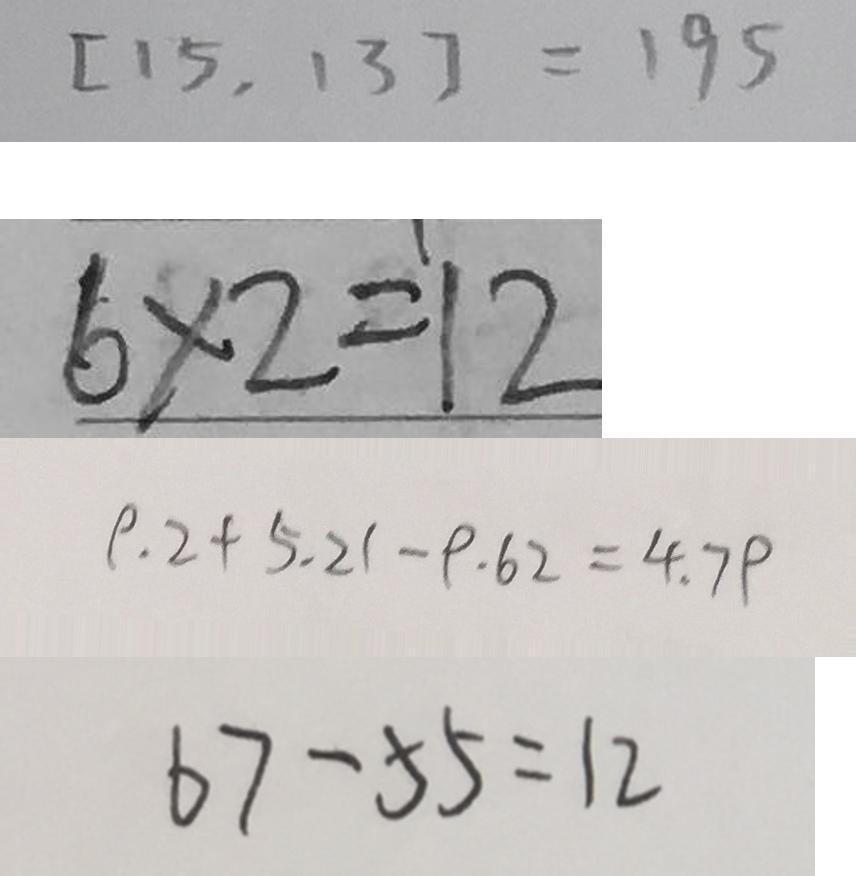<formula> <loc_0><loc_0><loc_500><loc_500>[ 1 5 , 1 3 ] = 1 9 5 
 6 \times 2 = 1 2 
 9 . 2 + 5 . 2 1 - 9 . 6 2 = 4 . 7 9 
 6 7 - 5 5 = 1 2</formula> 